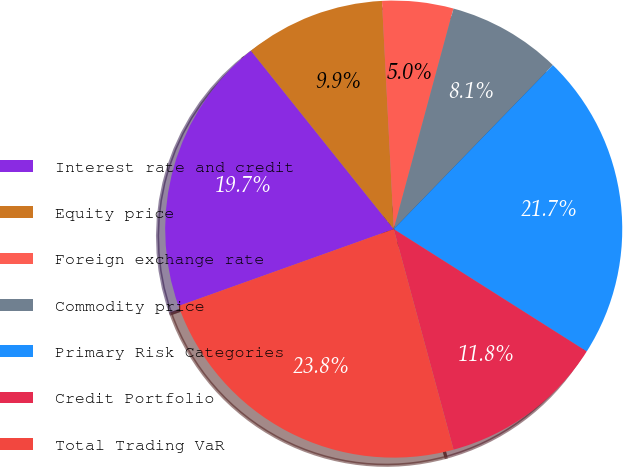Convert chart to OTSL. <chart><loc_0><loc_0><loc_500><loc_500><pie_chart><fcel>Interest rate and credit<fcel>Equity price<fcel>Foreign exchange rate<fcel>Commodity price<fcel>Primary Risk Categories<fcel>Credit Portfolio<fcel>Total Trading VaR<nl><fcel>19.72%<fcel>9.92%<fcel>5.03%<fcel>8.05%<fcel>21.73%<fcel>11.79%<fcel>23.75%<nl></chart> 